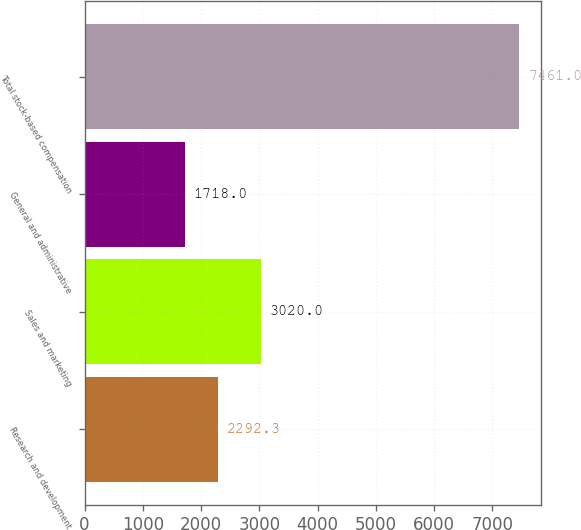Convert chart. <chart><loc_0><loc_0><loc_500><loc_500><bar_chart><fcel>Research and development<fcel>Sales and marketing<fcel>General and administrative<fcel>Total stock-based compensation<nl><fcel>2292.3<fcel>3020<fcel>1718<fcel>7461<nl></chart> 